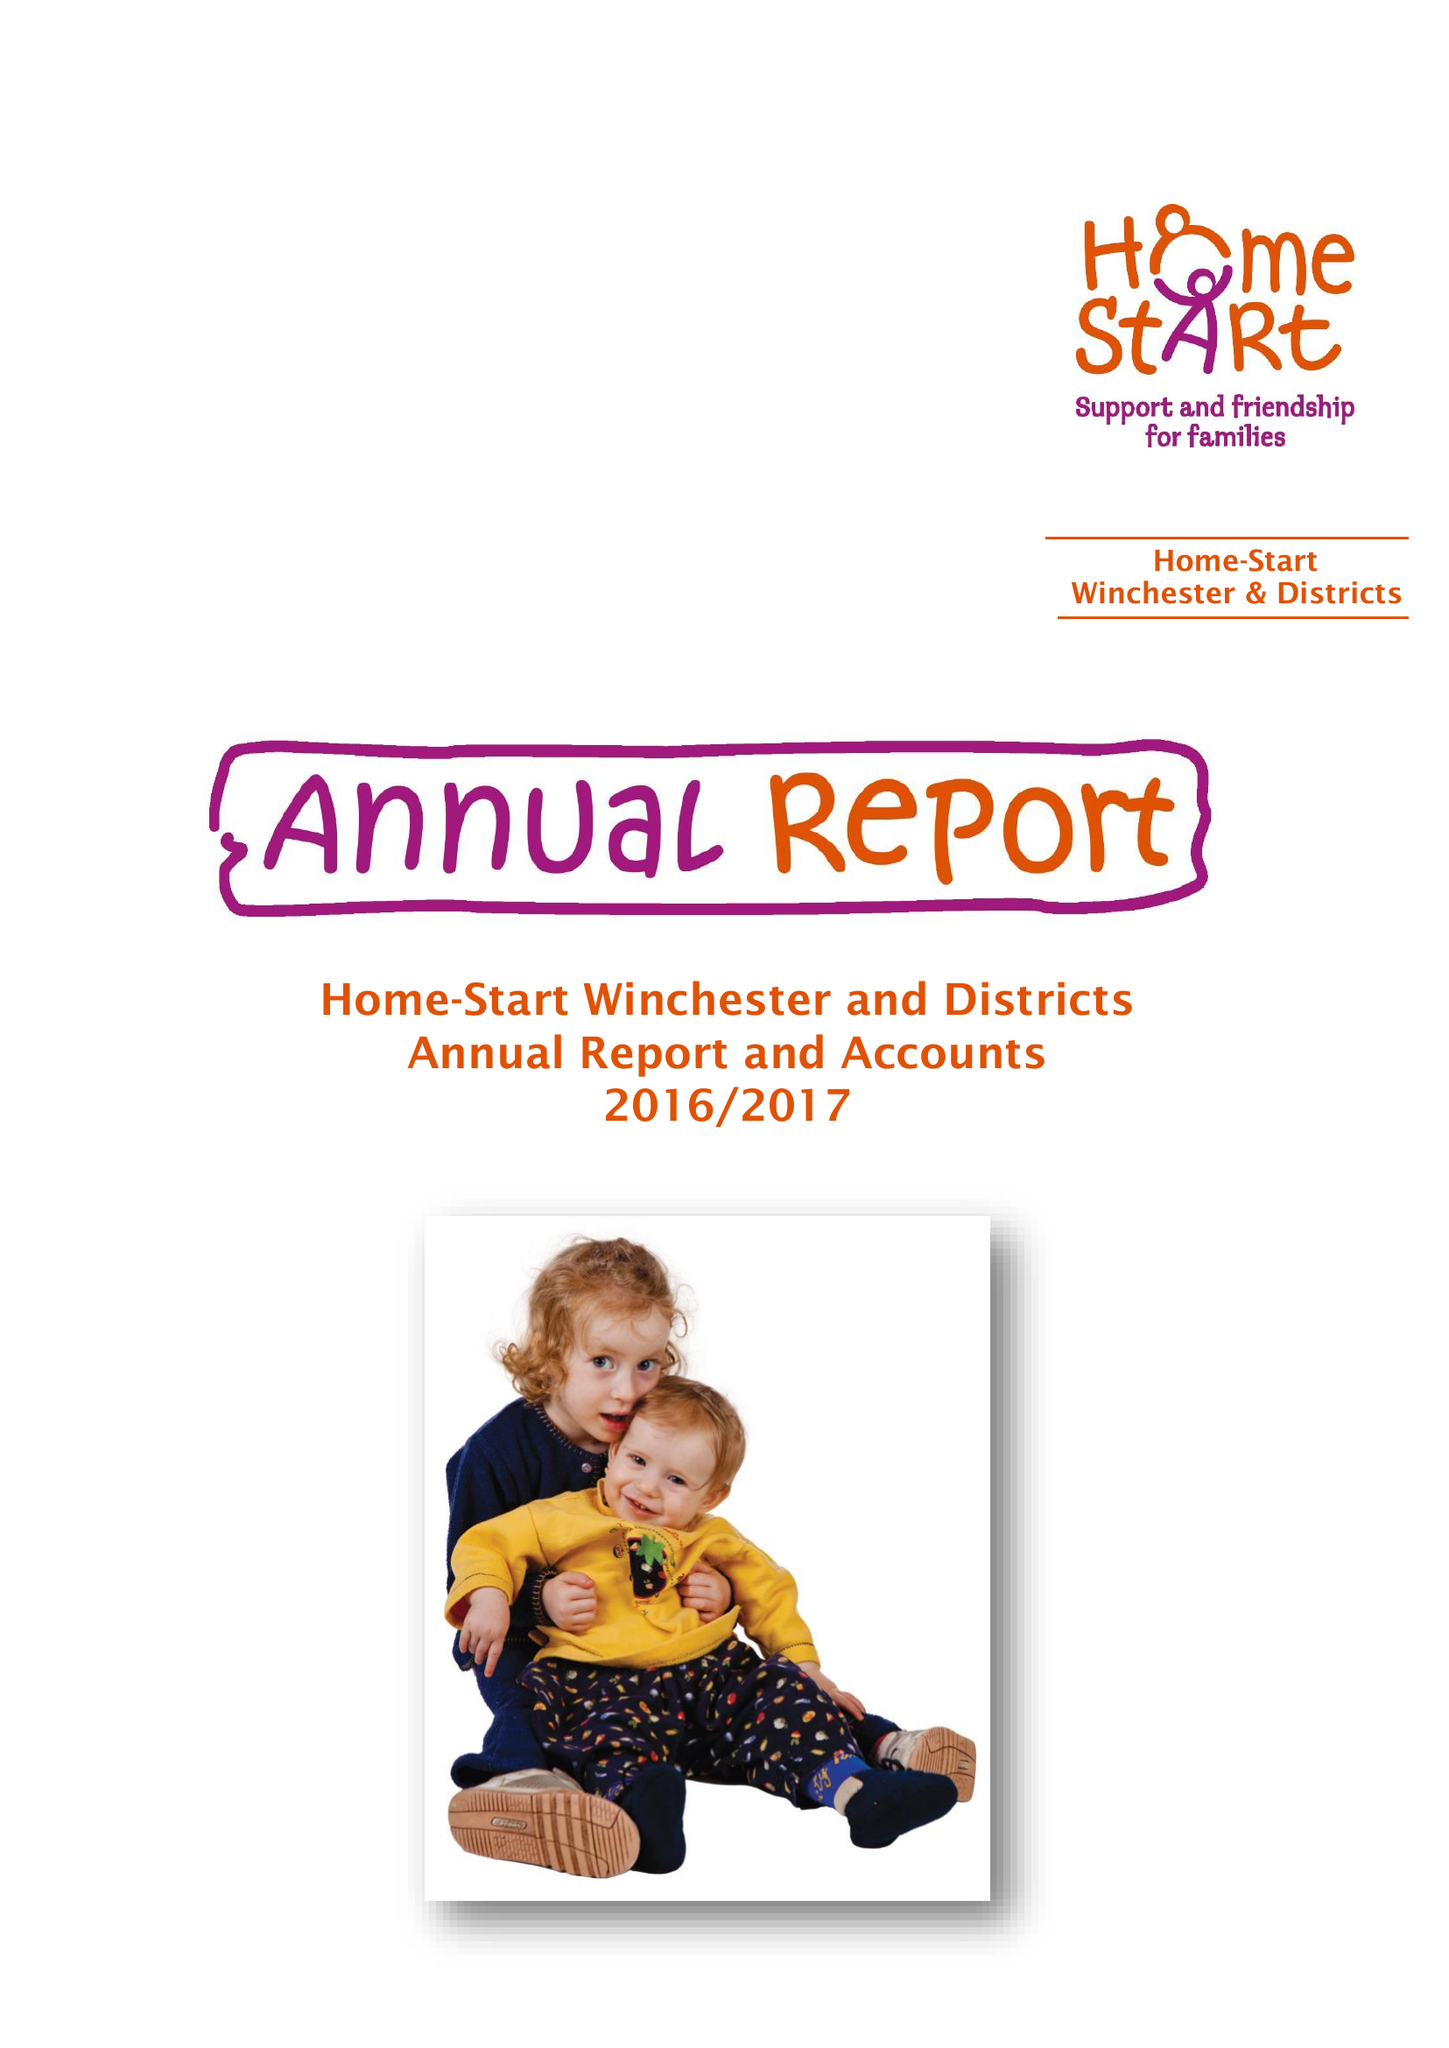What is the value for the address__postcode?
Answer the question using a single word or phrase. SO22 6AJ 